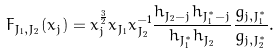<formula> <loc_0><loc_0><loc_500><loc_500>F _ { J _ { 1 } , J _ { 2 } } ( x _ { j } ) = x _ { j } ^ { \frac { 3 } { 2 } } x _ { J _ { 1 } } x ^ { - 1 } _ { J _ { 2 } } \frac { h _ { J _ { 2 } - j } h _ { \bar { J } _ { 1 } ^ { * } - \bar { j } } } { h _ { \bar { J } ^ { * } _ { 1 } } h _ { J _ { 2 } } } \frac { g _ { j , J _ { 1 } ^ { * } } } { g _ { j , J _ { 2 } ^ { * } } } .</formula> 